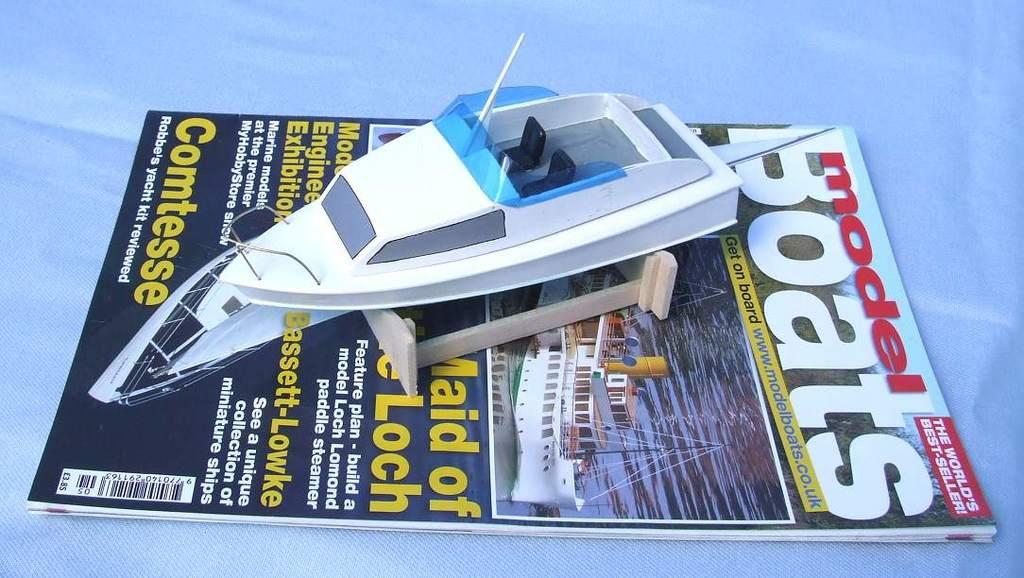What object is the main subject of the image? There is a book in the image. What is inside the book? The book contains a toy ship. What color is the background of the image? The background of the image is white. What is the price of the machine shown in the image? There is no machine present in the image; it features a book with a toy ship. How much has the growth of the plant in the image increased since last week? There is no plant present in the image; it features a book with a toy ship. 